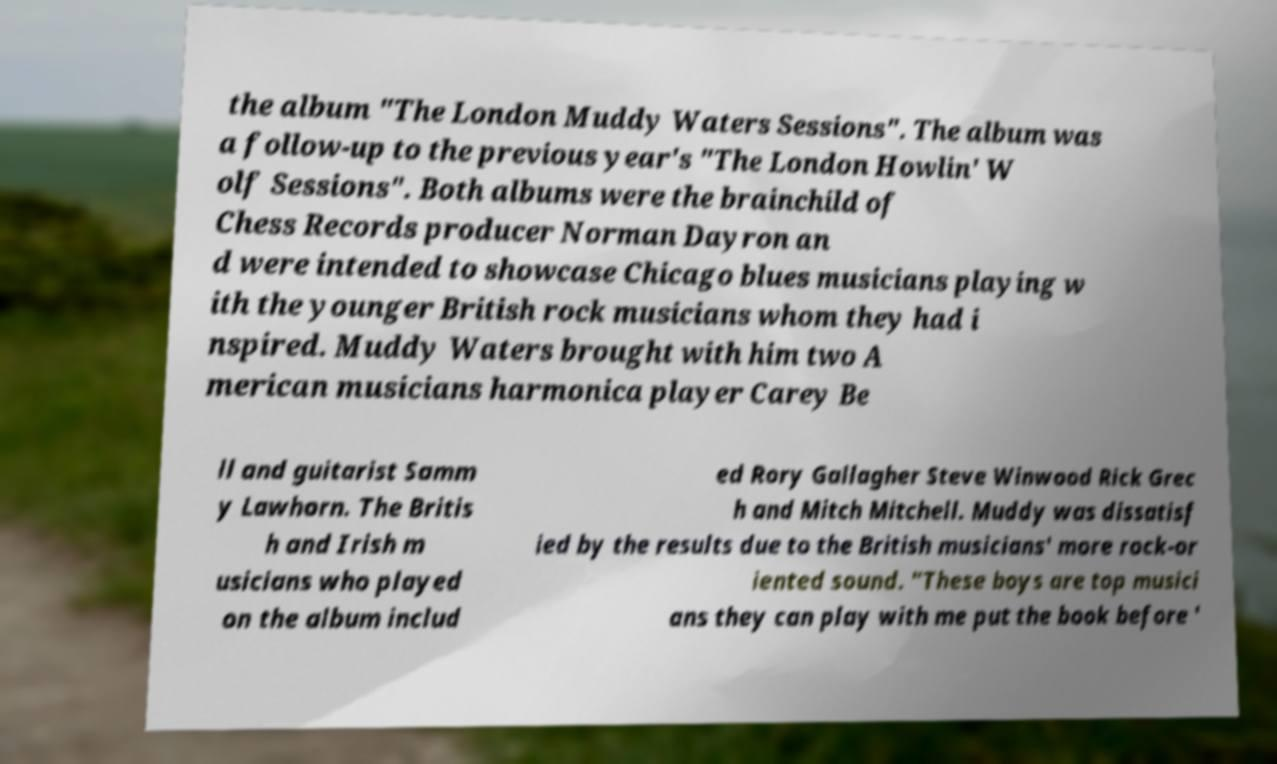I need the written content from this picture converted into text. Can you do that? the album "The London Muddy Waters Sessions". The album was a follow-up to the previous year's "The London Howlin' W olf Sessions". Both albums were the brainchild of Chess Records producer Norman Dayron an d were intended to showcase Chicago blues musicians playing w ith the younger British rock musicians whom they had i nspired. Muddy Waters brought with him two A merican musicians harmonica player Carey Be ll and guitarist Samm y Lawhorn. The Britis h and Irish m usicians who played on the album includ ed Rory Gallagher Steve Winwood Rick Grec h and Mitch Mitchell. Muddy was dissatisf ied by the results due to the British musicians' more rock-or iented sound. "These boys are top musici ans they can play with me put the book before ' 